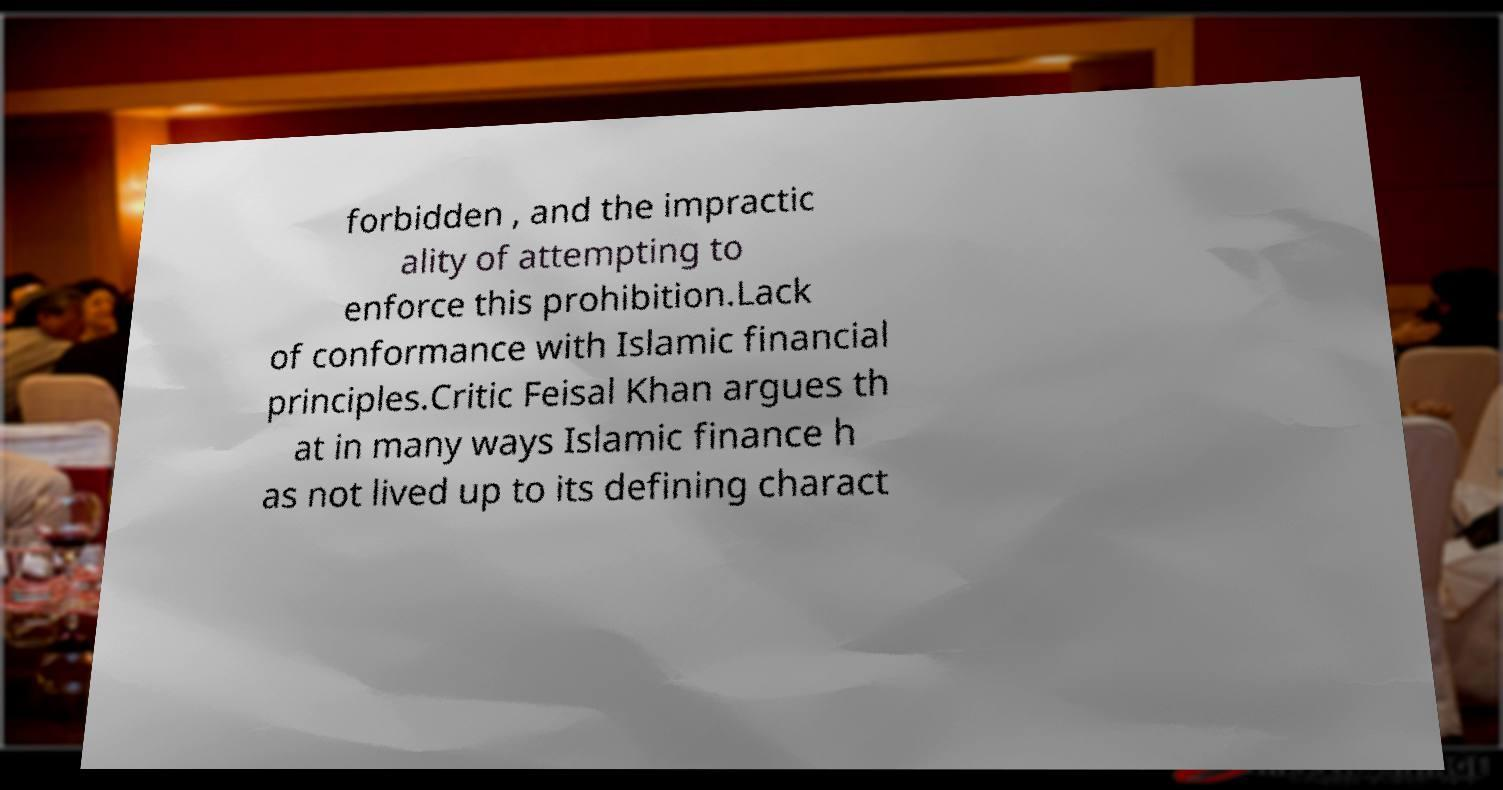Can you accurately transcribe the text from the provided image for me? forbidden , and the impractic ality of attempting to enforce this prohibition.Lack of conformance with Islamic financial principles.Critic Feisal Khan argues th at in many ways Islamic finance h as not lived up to its defining charact 